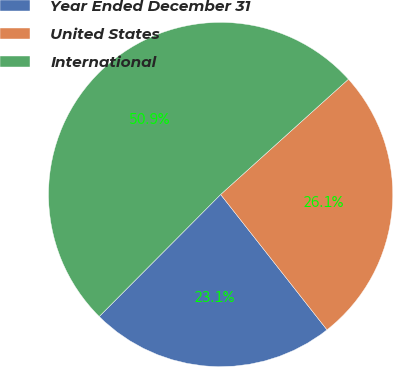<chart> <loc_0><loc_0><loc_500><loc_500><pie_chart><fcel>Year Ended December 31<fcel>United States<fcel>International<nl><fcel>23.06%<fcel>26.08%<fcel>50.86%<nl></chart> 